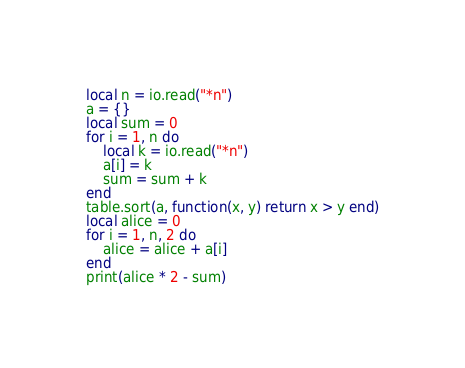Convert code to text. <code><loc_0><loc_0><loc_500><loc_500><_Lua_>local n = io.read("*n")
a = {}
local sum = 0
for i = 1, n do
    local k = io.read("*n")
    a[i] = k
    sum = sum + k
end
table.sort(a, function(x, y) return x > y end)
local alice = 0
for i = 1, n, 2 do
    alice = alice + a[i]
end
print(alice * 2 - sum)</code> 